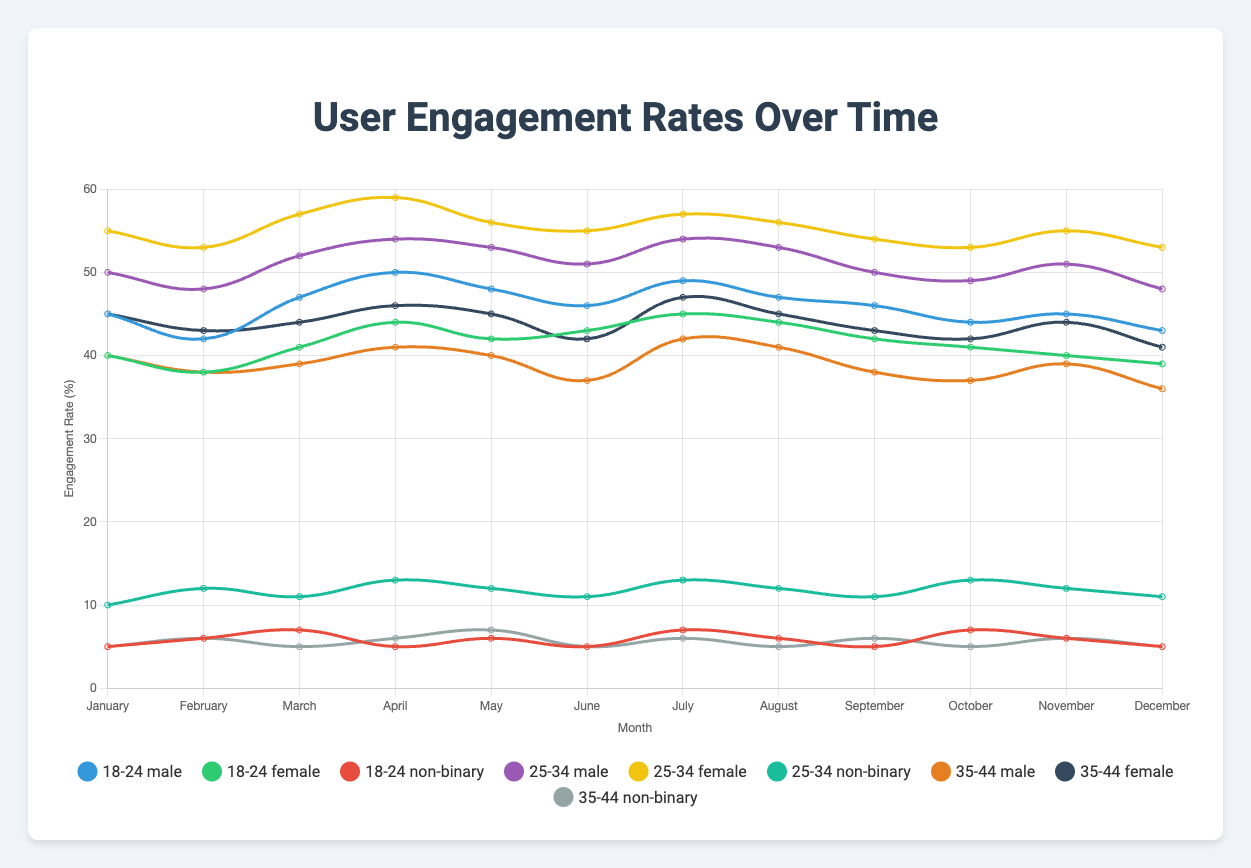What month did the 25-34 female demographic have the highest engagement rate? By looking at the line graph and locating the peak point for the 25-34 female demographic, we see that the engagement rate is the highest in April.
Answer: April Compare the engagement rates of 18-24 males and 35-44 females in July. Which was higher? By identifying the lines for 18-24 males and 35-44 females in July, we see that the 18-24 males had an engagement rate of 49%, while the 35-44 females had an engagement rate of 47%.
Answer: 18-24 males What is the average engagement rate for 18-24 non-binary users over the entire year? To find the average, we add up each month’s engagement rate for 18-24 non-binary users and divide by 12: (5 + 6 + 7 + 5 + 6 + 5 + 7 + 6 + 5 + 7 + 6 + 5) / 12 = 6%.
Answer: 6% Which demographic and gender had the lowest engagement rate in December? By checking the engagement rate for each demographic and gender in December, we find that 35-44 male had the lowest rate at 36%.
Answer: 35-44 male In which month did the 25-34 non-binary demographic have an engagement rate of 13%? By checking the engagement rates for 25-34 non-binary users across all months, we see that the rate was 13% in July and April.
Answer: July and April How much did the engagement rate for 18-24 males change from January to December? By noting the engagement rate for 18-24 males in January (45%) and in December (43%), we calculate the change as 43% - 45% = -2%.
Answer: -2% Did any demographic consistently have higher engagement over the year compared to others? By visually comparing the trends across demographics, we note that the 25-34 female demographic generally had higher engagement rates throughout the year.
Answer: 25-34 female Sum the engagement rates for the 35-44 non-binary demographic in the first half of the year. Adding the engagement rates for the first six months: (5 + 6 + 5 + 6 + 7 + 5) = 34%.
Answer: 34% Which demographic showed a noticeable peak in engagement in March? By identifying the peak points in March, the 25-34 male demographic showed a noticeable peak at 52%.
Answer: 25-34 male What trend can you see for the 18-24 female demographic from June to December? Observing the trend for 18-24 females from June (43%) to December (39%), there is a gradual decrease in engagement rates.
Answer: Gradual decrease 